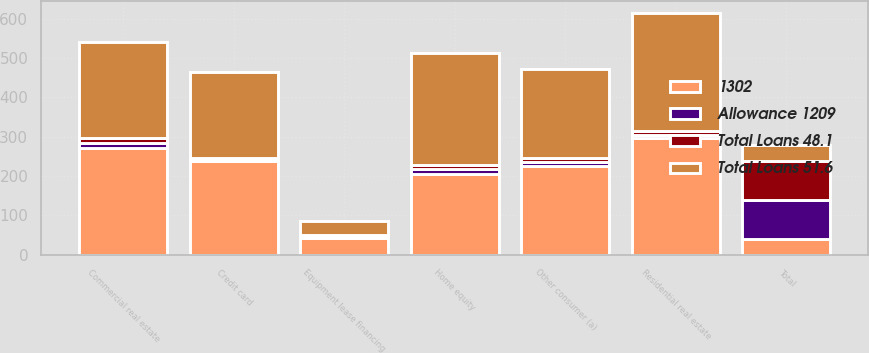<chart> <loc_0><loc_0><loc_500><loc_500><stacked_bar_chart><ecel><fcel>Commercial real estate<fcel>Equipment lease financing<fcel>Home equity<fcel>Residential real estate<fcel>Credit card<fcel>Other consumer (a)<fcel>Total<nl><fcel>1302<fcel>271<fcel>42<fcel>204<fcel>297<fcel>239<fcel>226<fcel>39<nl><fcel>Total Loans 48.1<fcel>12.4<fcel>3.2<fcel>11.6<fcel>8.3<fcel>2.8<fcel>10.1<fcel>100<nl><fcel>Total Loans 51.6<fcel>244<fcel>36<fcel>284<fcel>300<fcel>220<fcel>225<fcel>39<nl><fcel>Allowance 1209<fcel>13.1<fcel>3.6<fcel>12.9<fcel>7.8<fcel>2.6<fcel>9.9<fcel>100<nl></chart> 